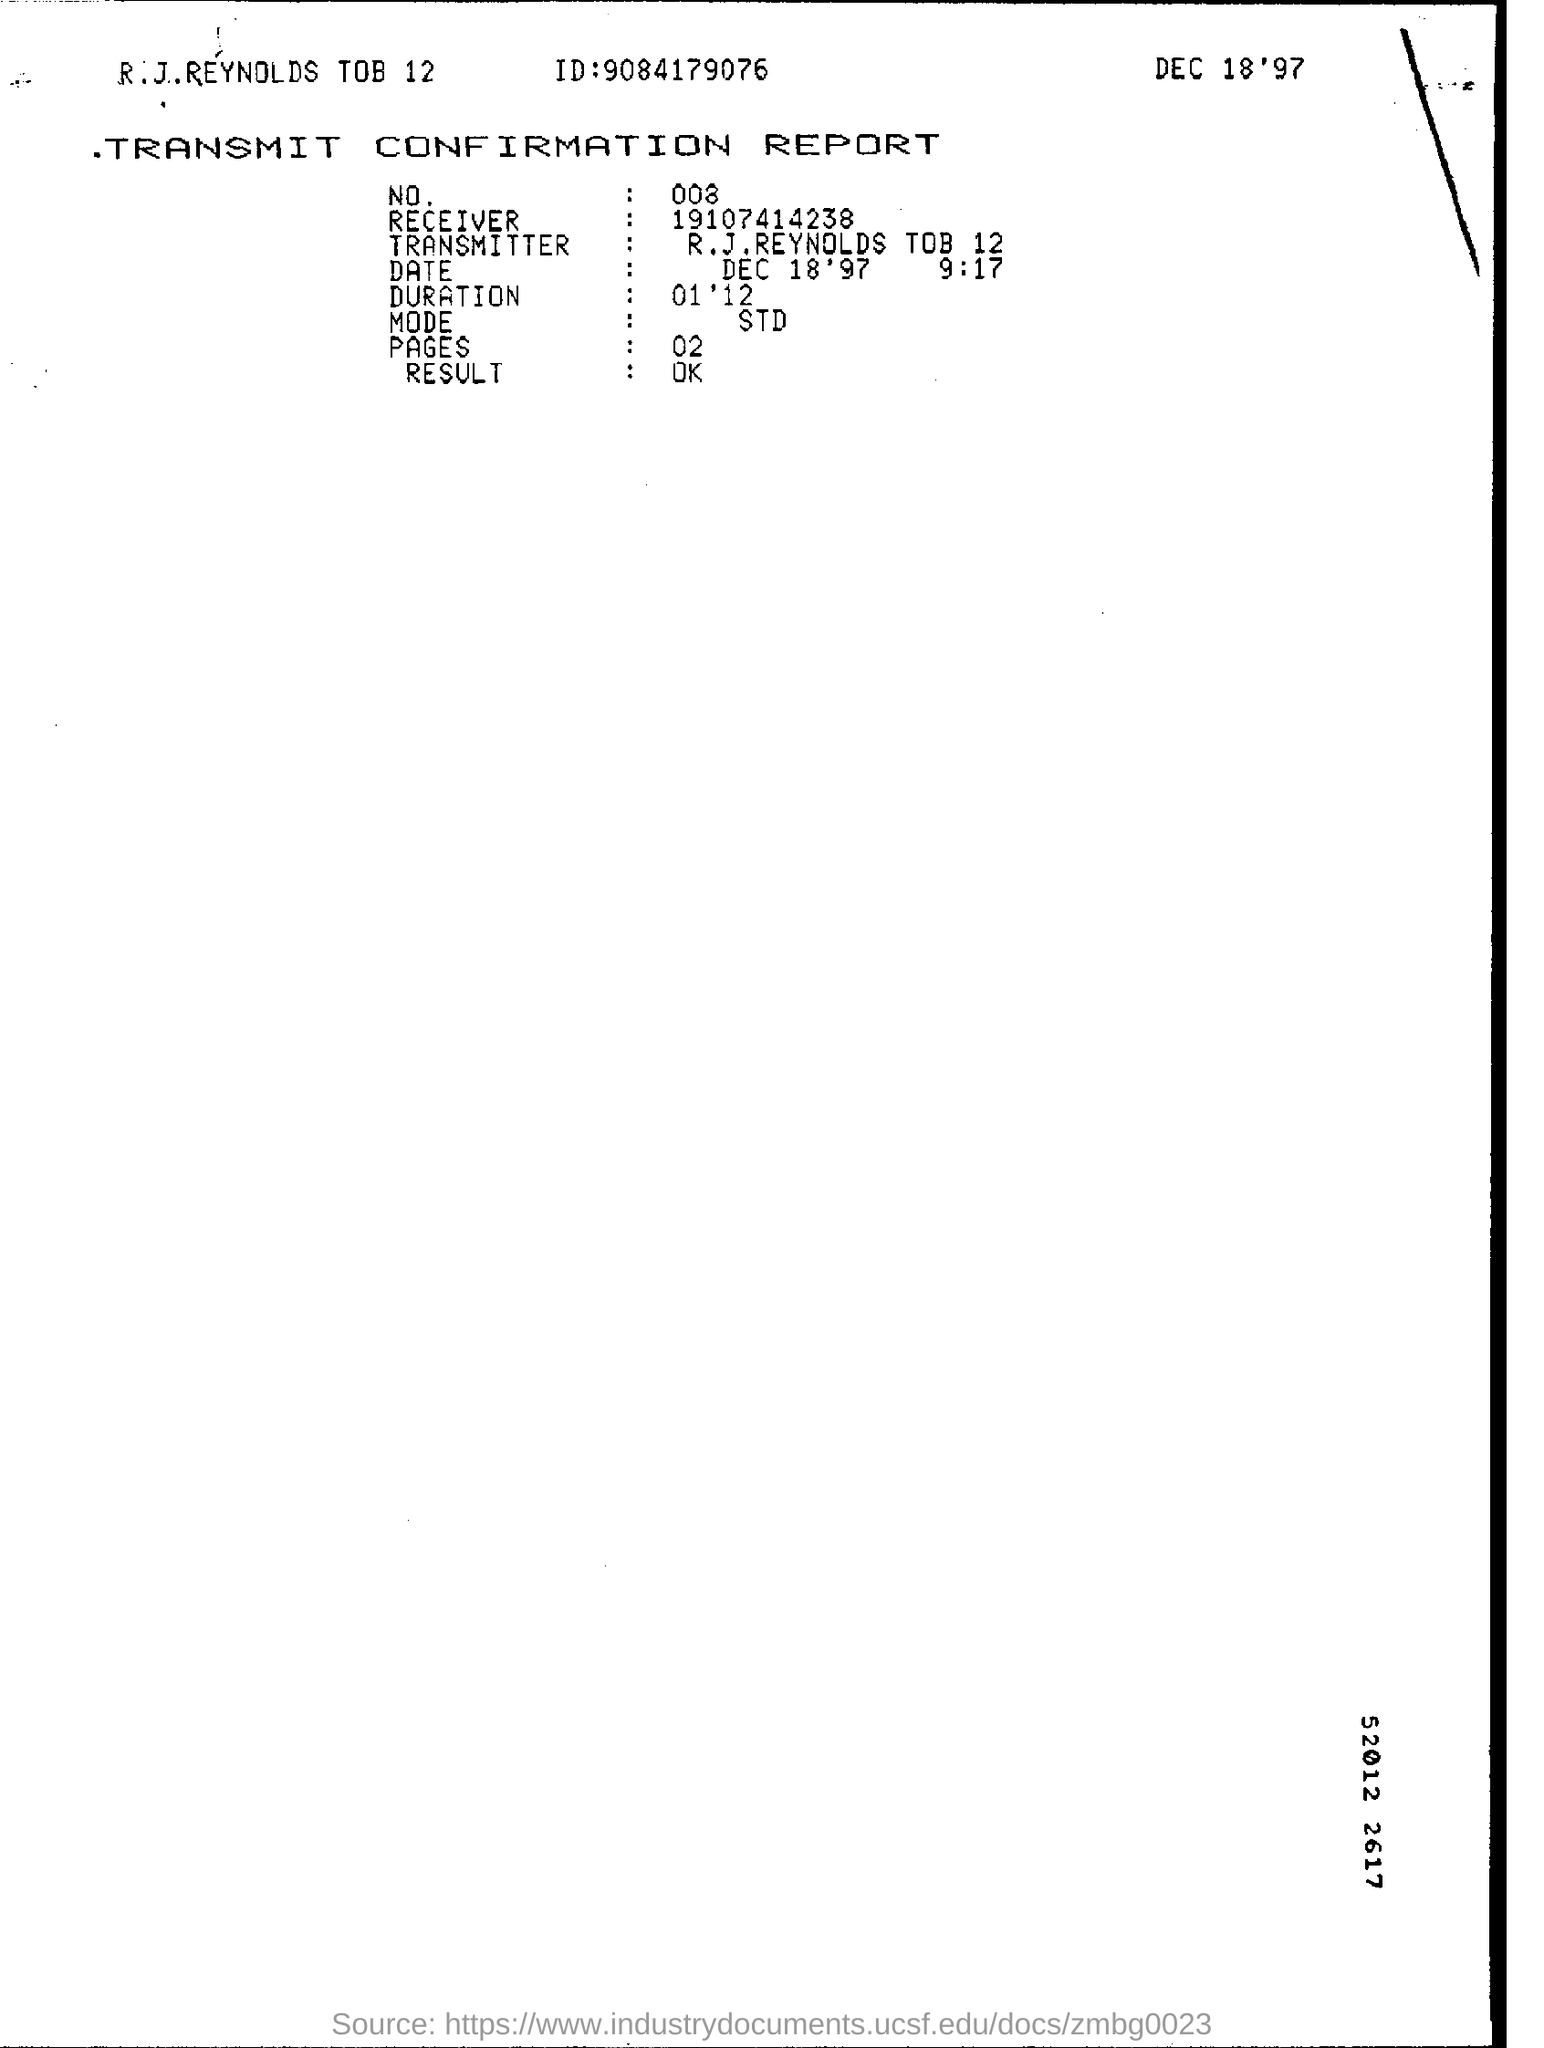What is the headding?
Make the answer very short. TRANSMIT CONFIRMATION REPORT. What is the ID?
Give a very brief answer. 9084179076. What is date shown at the top right corner?
Your response must be concise. DEC 18 '97. What is the NO.?
Provide a short and direct response. 008. What is the receiver?
Keep it short and to the point. 19107414238. What is the transmitter?
Provide a short and direct response. R.J.REYNOLDS TOB 12. What is the duration?
Keep it short and to the point. 01 ' 12. What is mode?
Your answer should be very brief. STD. What is the number of pages?
Provide a succinct answer. 02. What is the result?
Make the answer very short. OK. 